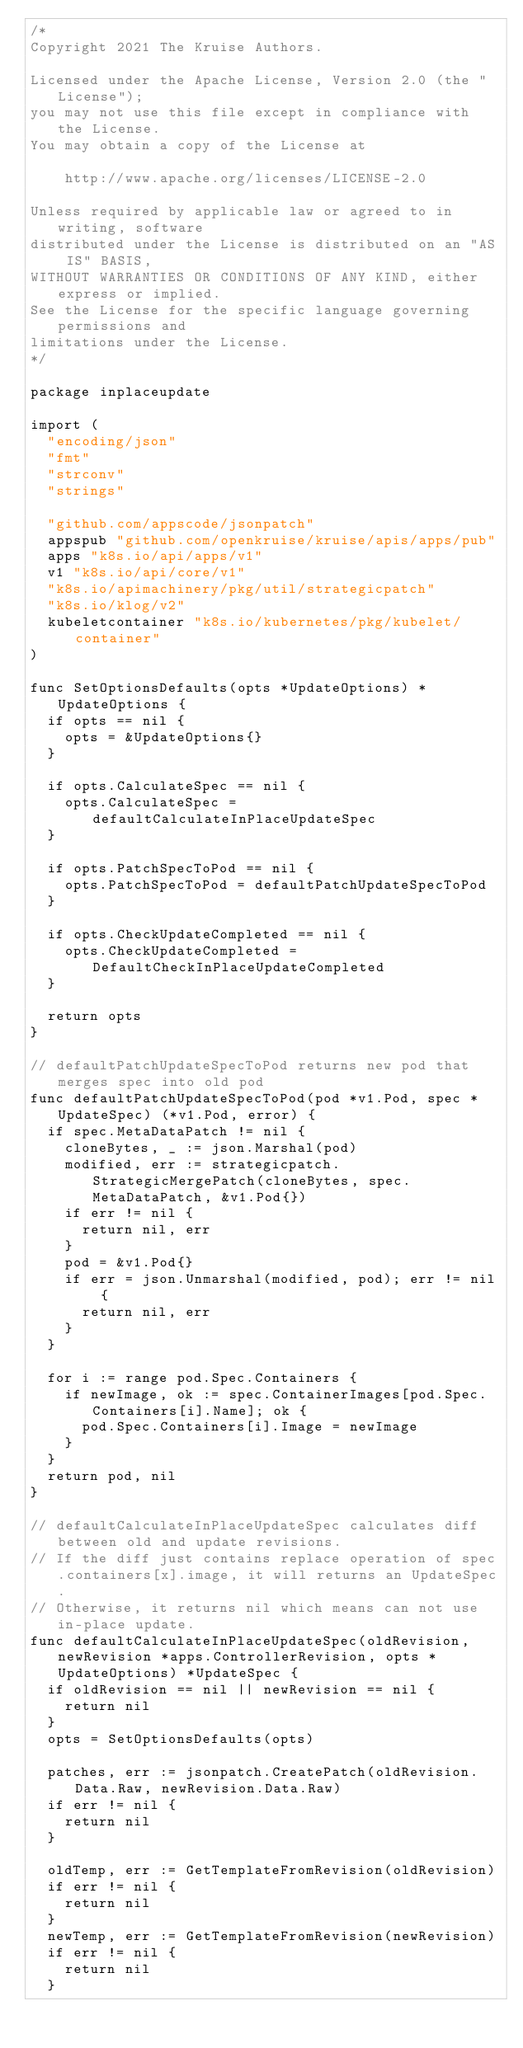Convert code to text. <code><loc_0><loc_0><loc_500><loc_500><_Go_>/*
Copyright 2021 The Kruise Authors.

Licensed under the Apache License, Version 2.0 (the "License");
you may not use this file except in compliance with the License.
You may obtain a copy of the License at

    http://www.apache.org/licenses/LICENSE-2.0

Unless required by applicable law or agreed to in writing, software
distributed under the License is distributed on an "AS IS" BASIS,
WITHOUT WARRANTIES OR CONDITIONS OF ANY KIND, either express or implied.
See the License for the specific language governing permissions and
limitations under the License.
*/

package inplaceupdate

import (
	"encoding/json"
	"fmt"
	"strconv"
	"strings"

	"github.com/appscode/jsonpatch"
	appspub "github.com/openkruise/kruise/apis/apps/pub"
	apps "k8s.io/api/apps/v1"
	v1 "k8s.io/api/core/v1"
	"k8s.io/apimachinery/pkg/util/strategicpatch"
	"k8s.io/klog/v2"
	kubeletcontainer "k8s.io/kubernetes/pkg/kubelet/container"
)

func SetOptionsDefaults(opts *UpdateOptions) *UpdateOptions {
	if opts == nil {
		opts = &UpdateOptions{}
	}

	if opts.CalculateSpec == nil {
		opts.CalculateSpec = defaultCalculateInPlaceUpdateSpec
	}

	if opts.PatchSpecToPod == nil {
		opts.PatchSpecToPod = defaultPatchUpdateSpecToPod
	}

	if opts.CheckUpdateCompleted == nil {
		opts.CheckUpdateCompleted = DefaultCheckInPlaceUpdateCompleted
	}

	return opts
}

// defaultPatchUpdateSpecToPod returns new pod that merges spec into old pod
func defaultPatchUpdateSpecToPod(pod *v1.Pod, spec *UpdateSpec) (*v1.Pod, error) {
	if spec.MetaDataPatch != nil {
		cloneBytes, _ := json.Marshal(pod)
		modified, err := strategicpatch.StrategicMergePatch(cloneBytes, spec.MetaDataPatch, &v1.Pod{})
		if err != nil {
			return nil, err
		}
		pod = &v1.Pod{}
		if err = json.Unmarshal(modified, pod); err != nil {
			return nil, err
		}
	}

	for i := range pod.Spec.Containers {
		if newImage, ok := spec.ContainerImages[pod.Spec.Containers[i].Name]; ok {
			pod.Spec.Containers[i].Image = newImage
		}
	}
	return pod, nil
}

// defaultCalculateInPlaceUpdateSpec calculates diff between old and update revisions.
// If the diff just contains replace operation of spec.containers[x].image, it will returns an UpdateSpec.
// Otherwise, it returns nil which means can not use in-place update.
func defaultCalculateInPlaceUpdateSpec(oldRevision, newRevision *apps.ControllerRevision, opts *UpdateOptions) *UpdateSpec {
	if oldRevision == nil || newRevision == nil {
		return nil
	}
	opts = SetOptionsDefaults(opts)

	patches, err := jsonpatch.CreatePatch(oldRevision.Data.Raw, newRevision.Data.Raw)
	if err != nil {
		return nil
	}

	oldTemp, err := GetTemplateFromRevision(oldRevision)
	if err != nil {
		return nil
	}
	newTemp, err := GetTemplateFromRevision(newRevision)
	if err != nil {
		return nil
	}
</code> 